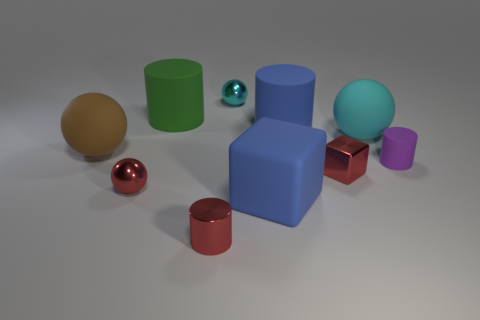Subtract all cylinders. How many objects are left? 6 Add 5 brown spheres. How many brown spheres are left? 6 Add 7 purple cylinders. How many purple cylinders exist? 8 Subtract 0 gray balls. How many objects are left? 10 Subtract all brown rubber balls. Subtract all big green rubber objects. How many objects are left? 8 